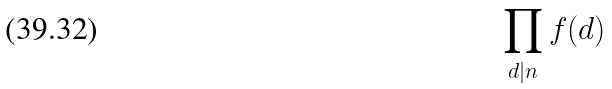<formula> <loc_0><loc_0><loc_500><loc_500>\prod _ { d | n } f ( d )</formula> 